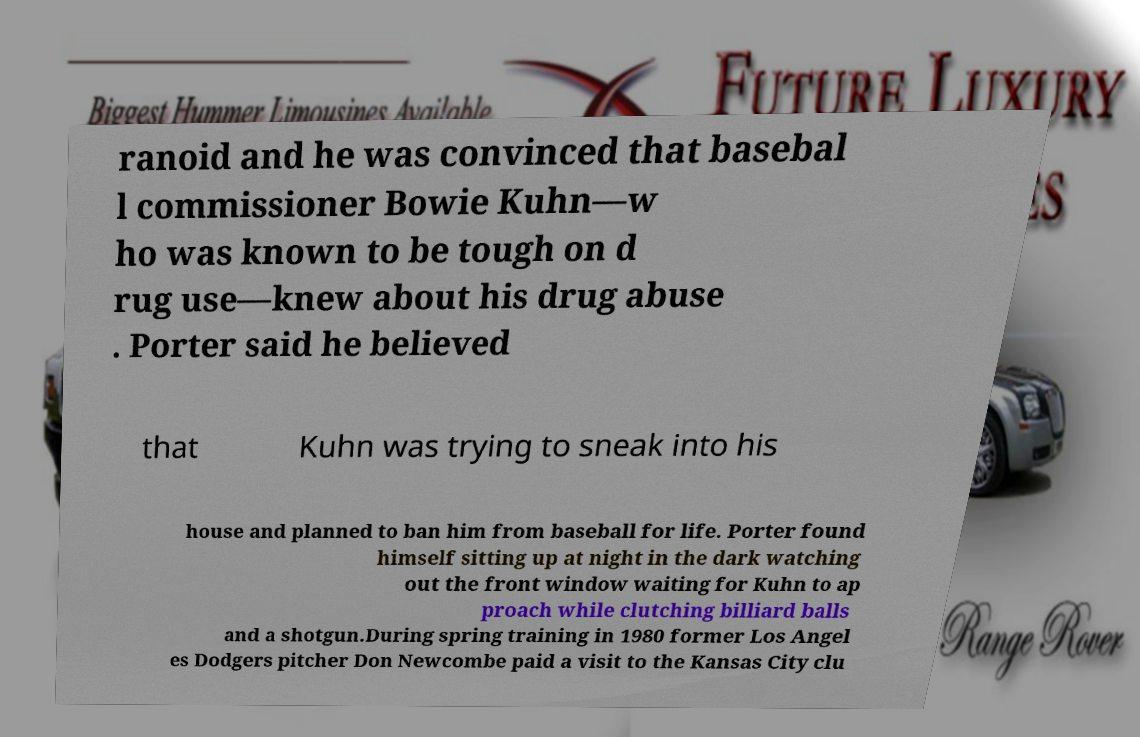Please read and relay the text visible in this image. What does it say? ranoid and he was convinced that basebal l commissioner Bowie Kuhn—w ho was known to be tough on d rug use—knew about his drug abuse . Porter said he believed that Kuhn was trying to sneak into his house and planned to ban him from baseball for life. Porter found himself sitting up at night in the dark watching out the front window waiting for Kuhn to ap proach while clutching billiard balls and a shotgun.During spring training in 1980 former Los Angel es Dodgers pitcher Don Newcombe paid a visit to the Kansas City clu 